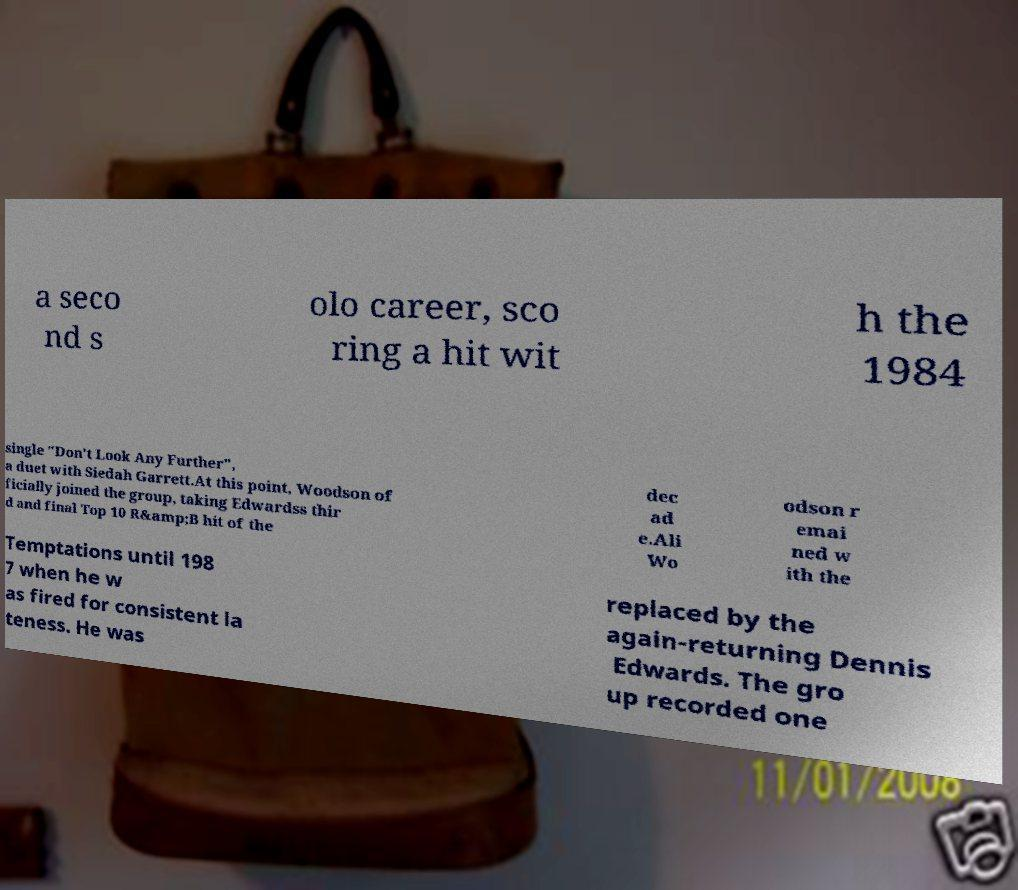Please identify and transcribe the text found in this image. a seco nd s olo career, sco ring a hit wit h the 1984 single "Don't Look Any Further", a duet with Siedah Garrett.At this point, Woodson of ficially joined the group, taking Edwardss thir d and final Top 10 R&amp;B hit of the dec ad e.Ali Wo odson r emai ned w ith the Temptations until 198 7 when he w as fired for consistent la teness. He was replaced by the again-returning Dennis Edwards. The gro up recorded one 